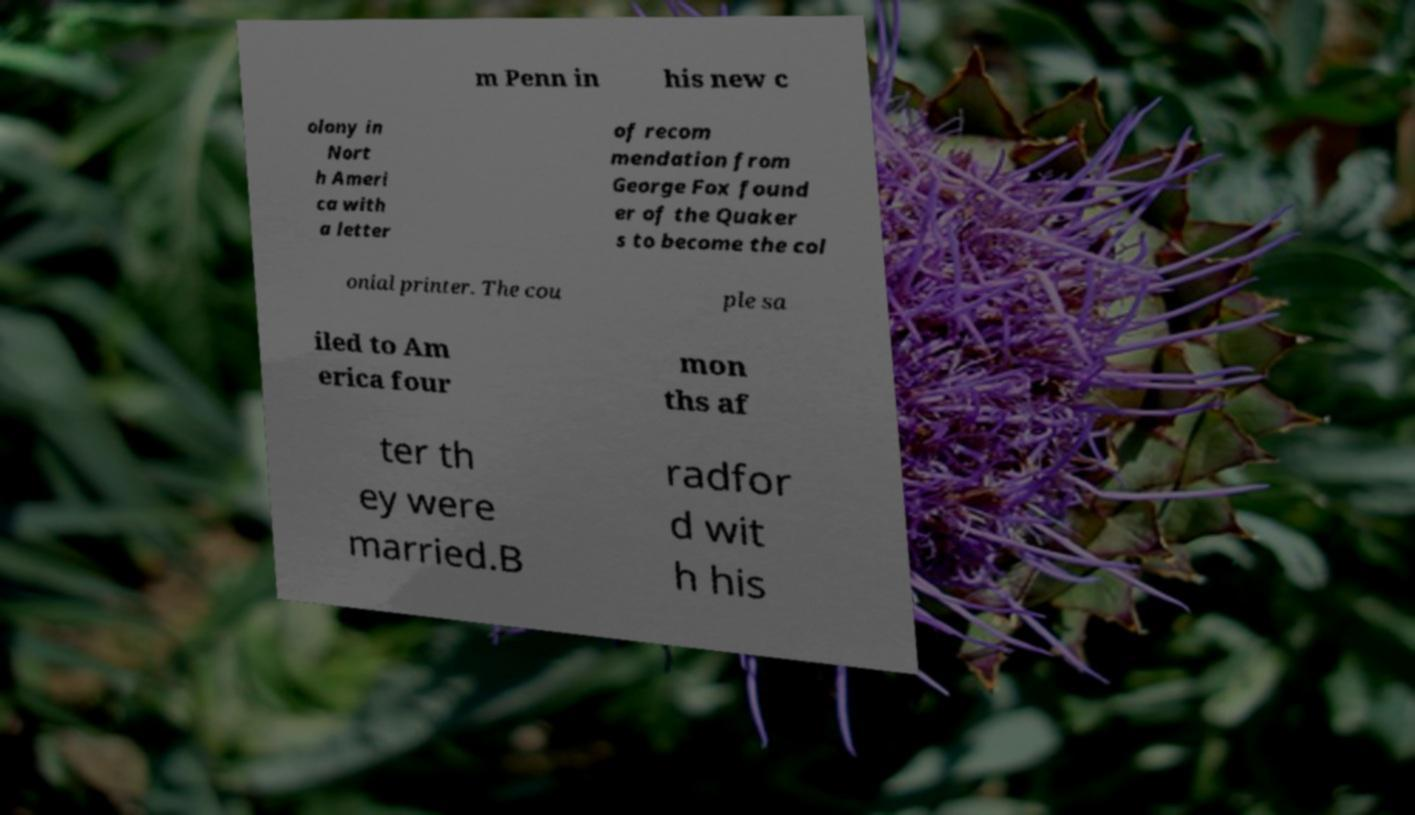For documentation purposes, I need the text within this image transcribed. Could you provide that? m Penn in his new c olony in Nort h Ameri ca with a letter of recom mendation from George Fox found er of the Quaker s to become the col onial printer. The cou ple sa iled to Am erica four mon ths af ter th ey were married.B radfor d wit h his 